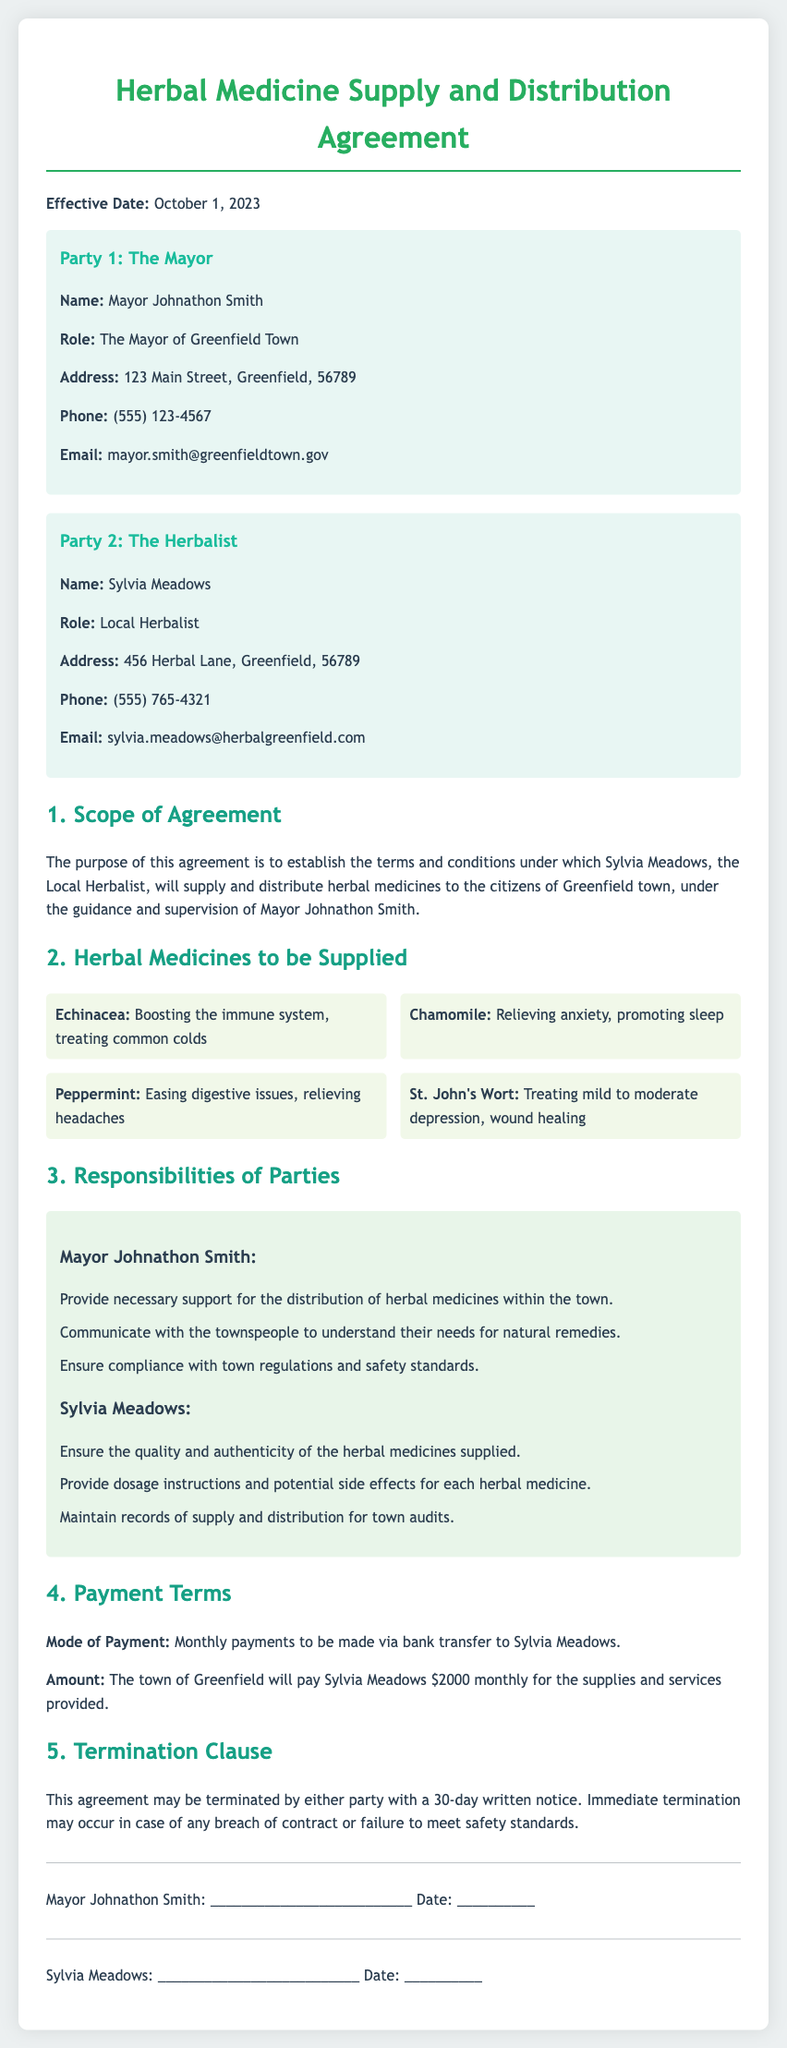What is the effective date of the agreement? The effective date is mentioned prominently at the beginning of the document under the title.
Answer: October 1, 2023 Who is Party 1 in the agreement? Party 1 is identified as the mayor, along with specific details provided in the document.
Answer: Mayor Johnathon Smith How much will the town of Greenfield pay monthly? The payment term section clearly states the specific monthly payment amount to be made.
Answer: $2000 What must Sylvia Meadows ensure regarding the herbal medicines? The responsibilities section outlines key expectations for Sylvia Meadows regarding the products supplied.
Answer: Quality and authenticity What is required for termination of the agreement? The termination clause specifies the conditions under which either party may terminate the contract.
Answer: 30-day written notice What role does Mayor Johnathon Smith play in this agreement? The document specifies the responsibilities assigned to the mayor within the context of this agreement.
Answer: The Mayor of Greenfield Town What is one of the responsibilities of Sylvia Meadows? The section detailing responsibilities provides multiple tasks expected of Sylvia Meadows in the agreement.
Answer: Provide dosage instructions Which herb is mentioned as treating common colds? The list of herbal medicines includes descriptions that pinpoint specific uses for each herb mentioned.
Answer: Echinacea 